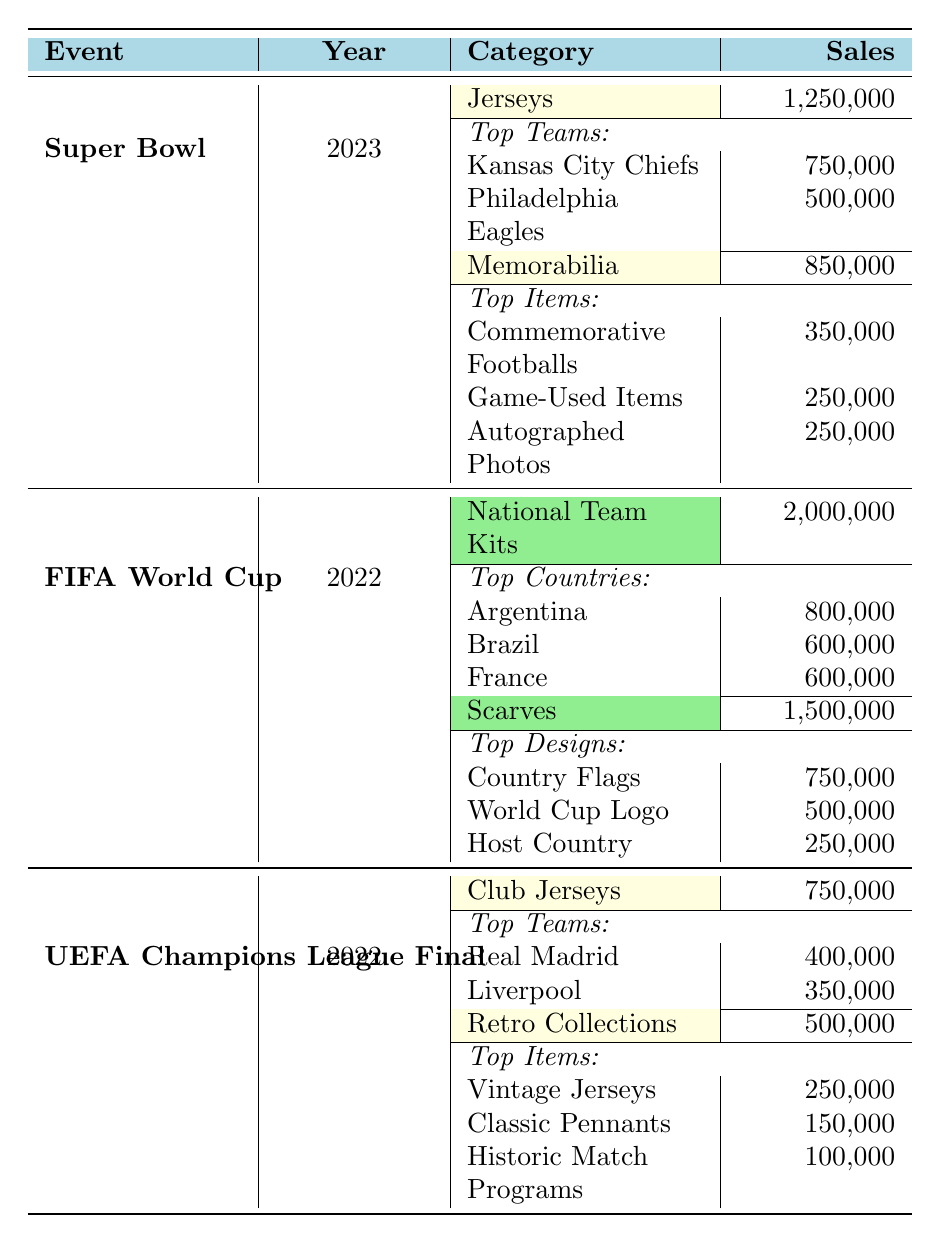What were the total sales for merchandise during the Super Bowl in 2023? To find the total sales for merchandise during the Super Bowl in 2023, I refer to the table where it lists the sales for Jerseys (1,250,000) and Memorabilia (850,000). Adding these together gives: 1,250,000 + 850,000 = 2,100,000.
Answer: 2,100,000 Which category had the highest sales during the FIFA World Cup in 2022? Looking at the table, I see that the National Team Kits had sales of 2,000,000 and Scarves had 1,500,000. Since 2,000,000 is greater than 1,500,000, National Team Kits is the category with the highest sales.
Answer: National Team Kits How many units of retro collections were sold during the UEFA Champions League Final in 2022? From the table, the sales for Retro Collections under the UEFA Champions League Final in 2022 are listed as 500,000.
Answer: 500,000 What was the total sales of top teams’ jerseys during the Super Bowl in 2023? In the Super Bowl table, the jerseys sold for the Kansas City Chiefs totaled 750,000 units and for the Philadelphia Eagles, it was 500,000 units. By adding these, I get: 750,000 + 500,000 = 1,250,000.
Answer: 1,250,000 Did memorabilia sales during the Super Bowl exceed that of jerseys in 2023? The table shows that memorabilia sales were 850,000 while jersey sales were 1,250,000. Since 850,000 is less than 1,250,000, the statement is false.
Answer: No Which country had the second highest sales of National Team Kits during the FIFA World Cup in 2022? The National Team Kits sales show Argentina at 800,000, Brazil at 600,000, and France also at 600,000. Since Brazil is the only country with sales distinctly lower than Argentina, Brazil is second.
Answer: Brazil What is the total sales from memorabilia and scarves combined? The sales for memorabilia during the Super Bowl is 850,000, and for scarves during the FIFA World Cup it is 1,500,000. Adding these together gives: 850,000 + 1,500,000 = 2,350,000.
Answer: 2,350,000 Which event had higher overall merchandise sales, the UEFA Champions League Final in 2022 or the Super Bowl in 2023? From the Super Bowl, total sales are 2,100,000 (1,250,000 jerseys + 850,000 memorabilia). For UEFA Champions League, the total is 1,250,000 (750,000 club jerseys + 500,000 retro collections). Comparing, 2,100,000 is greater than 1,250,000. Thus, the Super Bowl had higher sales.
Answer: Super Bowl How many total units were sold for the top item in memorabilia during the Super Bowl? The top item in memorabilia is Commemorative Footballs with 350,000 units sold, which is the value directly listed under the Super Bowl category.
Answer: 350,000 Is it true that the most units sold for scarves in the FIFA World Cup were for the World Cup Logo? The table shows Country Flags at 750,000 units, World Cup Logo at 500,000 units, and Host Country at 250,000. Thus, the most units sold were for Country Flags, making the statement false.
Answer: No 